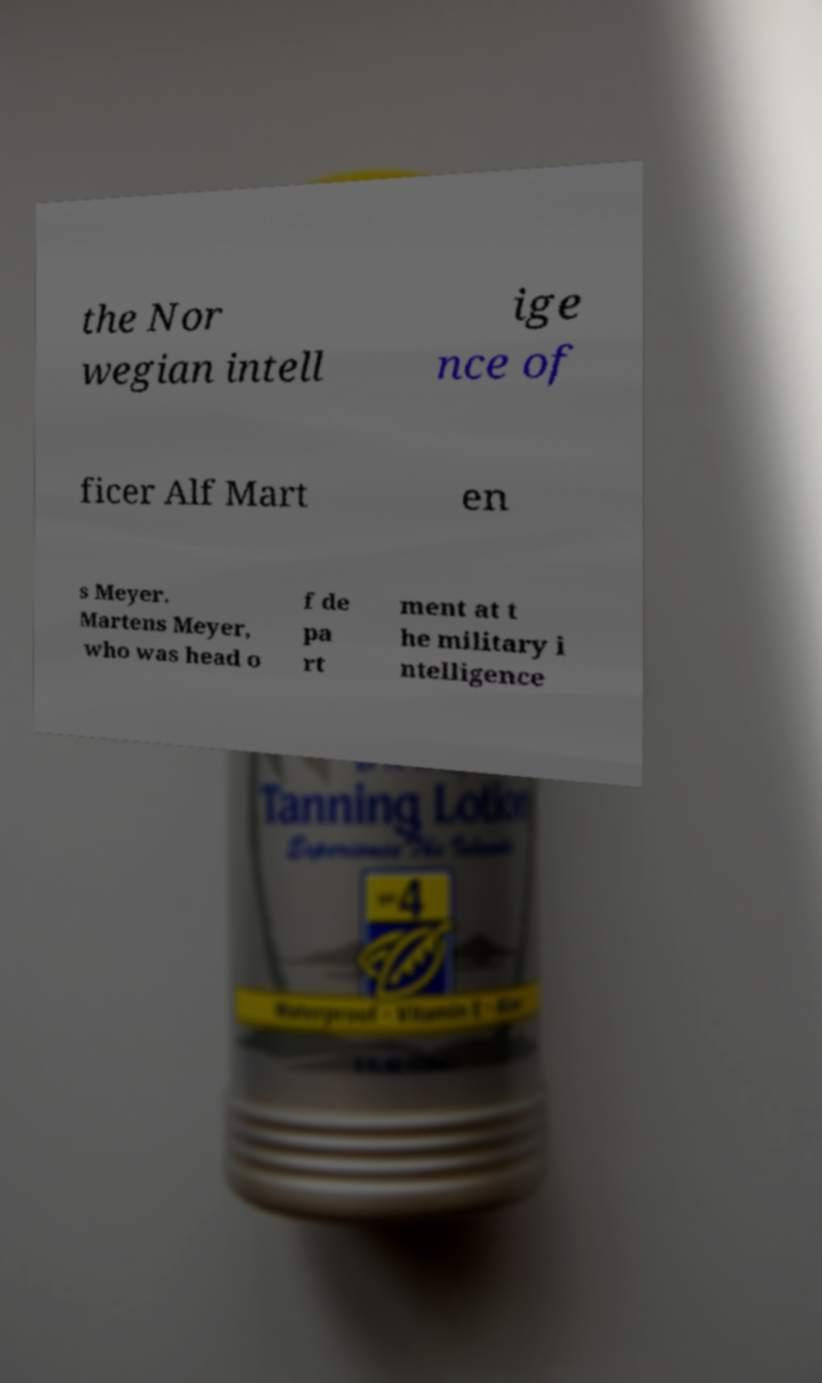Could you assist in decoding the text presented in this image and type it out clearly? the Nor wegian intell ige nce of ficer Alf Mart en s Meyer. Martens Meyer, who was head o f de pa rt ment at t he military i ntelligence 